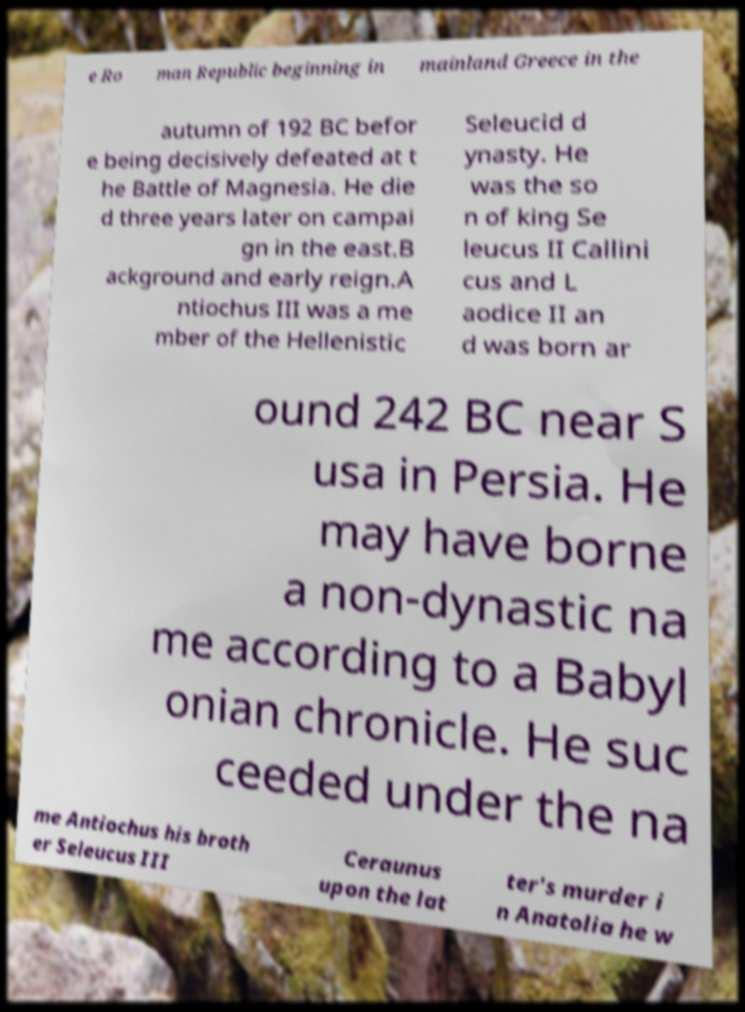Could you extract and type out the text from this image? e Ro man Republic beginning in mainland Greece in the autumn of 192 BC befor e being decisively defeated at t he Battle of Magnesia. He die d three years later on campai gn in the east.B ackground and early reign.A ntiochus III was a me mber of the Hellenistic Seleucid d ynasty. He was the so n of king Se leucus II Callini cus and L aodice II an d was born ar ound 242 BC near S usa in Persia. He may have borne a non-dynastic na me according to a Babyl onian chronicle. He suc ceeded under the na me Antiochus his broth er Seleucus III Ceraunus upon the lat ter's murder i n Anatolia he w 